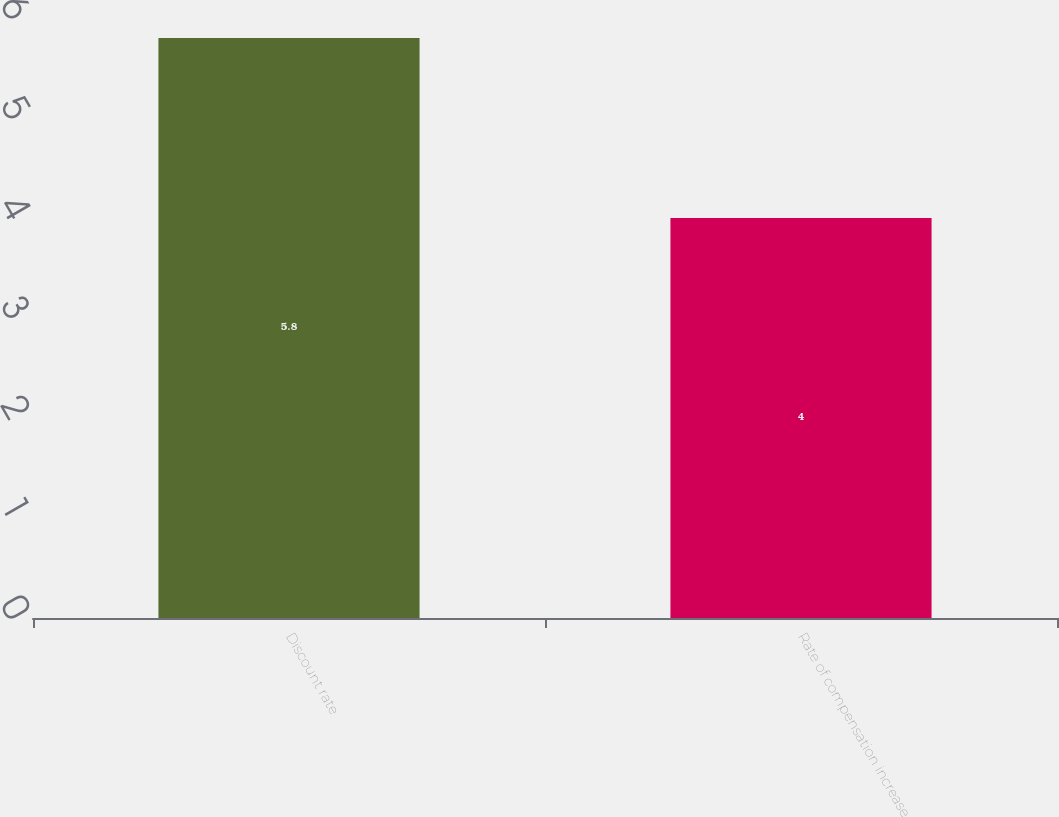Convert chart to OTSL. <chart><loc_0><loc_0><loc_500><loc_500><bar_chart><fcel>Discount rate<fcel>Rate of compensation increase<nl><fcel>5.8<fcel>4<nl></chart> 